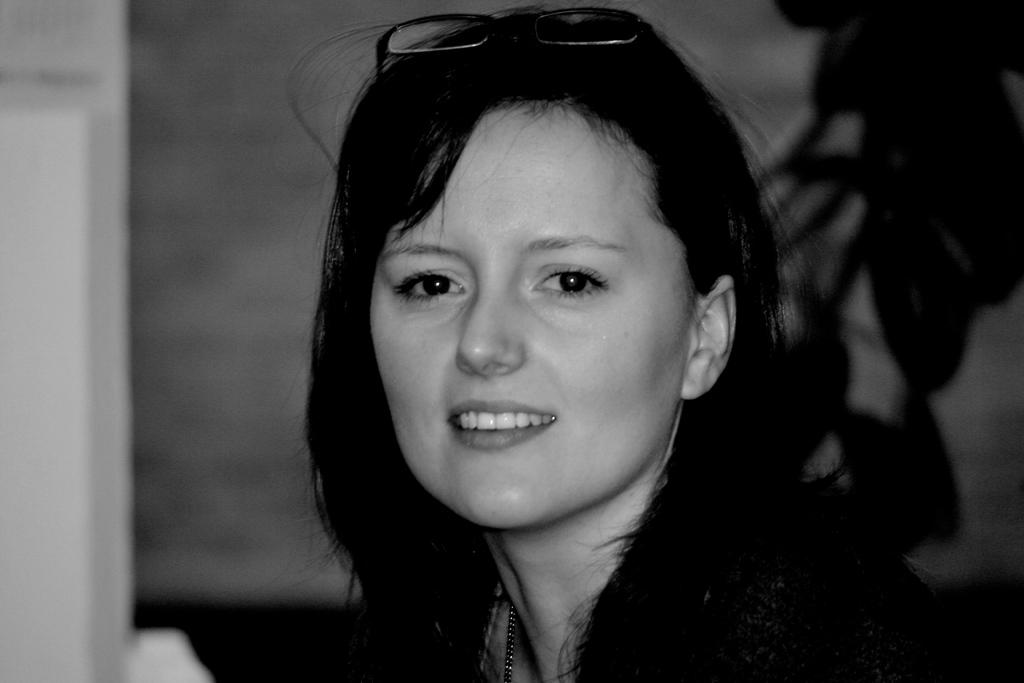Who is present in the image? There is a woman in the image. What can be seen in the background of the image? There is a plant and a wall in the background of the image. Can you describe the architectural feature on the left side of the image? There appears to be a door on the left side of the image. What book is the woman reading in space in the image? There is no book or space depicted in the image; it features a woman in a setting with a plant, a wall, and a door. 